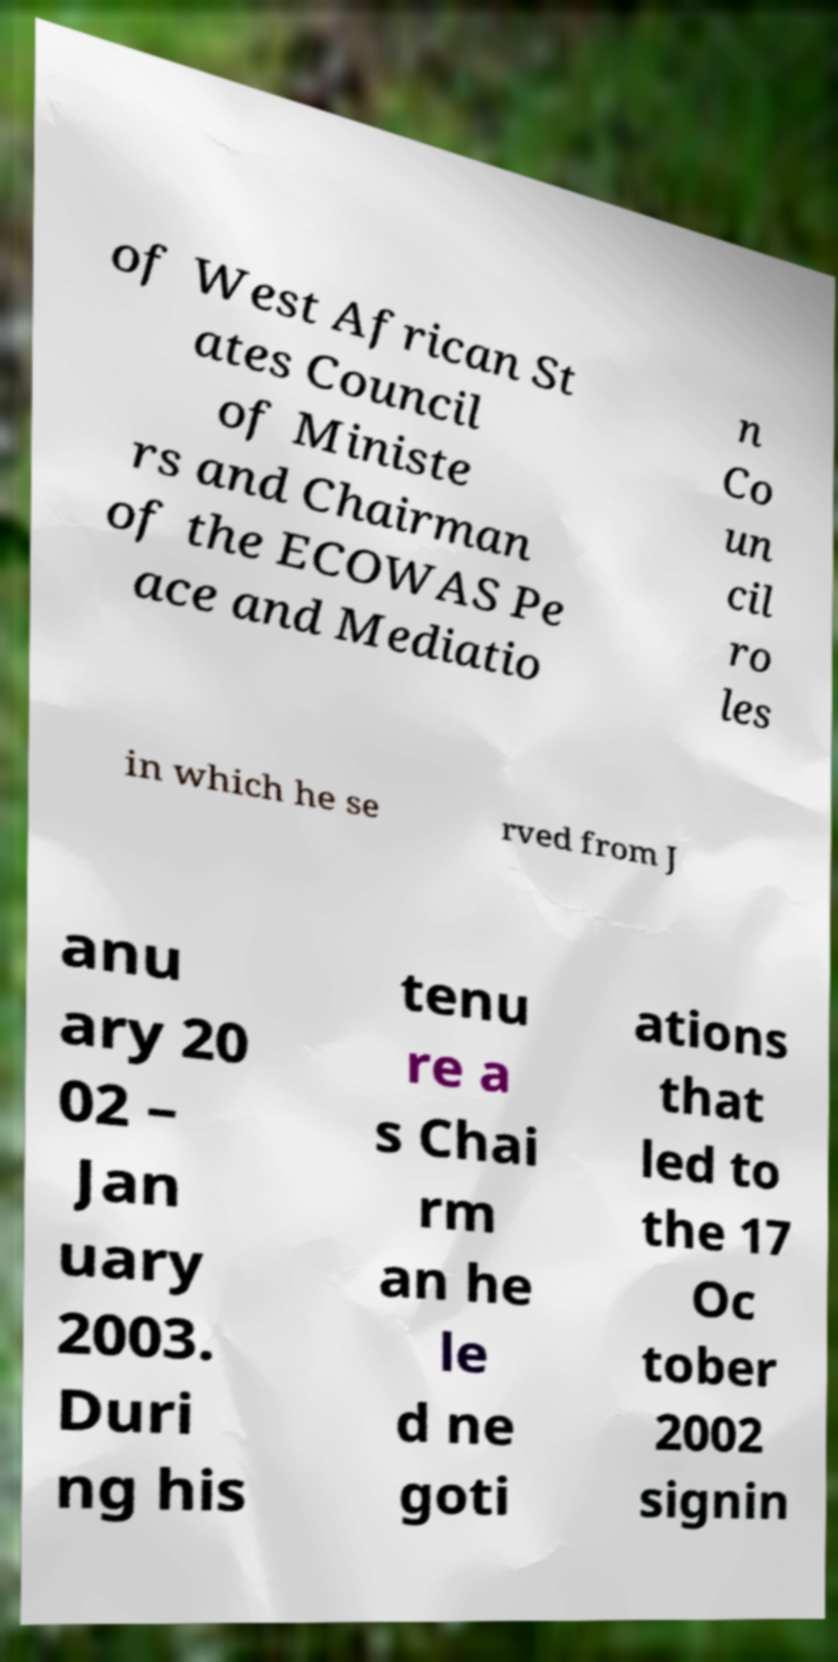I need the written content from this picture converted into text. Can you do that? of West African St ates Council of Ministe rs and Chairman of the ECOWAS Pe ace and Mediatio n Co un cil ro les in which he se rved from J anu ary 20 02 – Jan uary 2003. Duri ng his tenu re a s Chai rm an he le d ne goti ations that led to the 17 Oc tober 2002 signin 